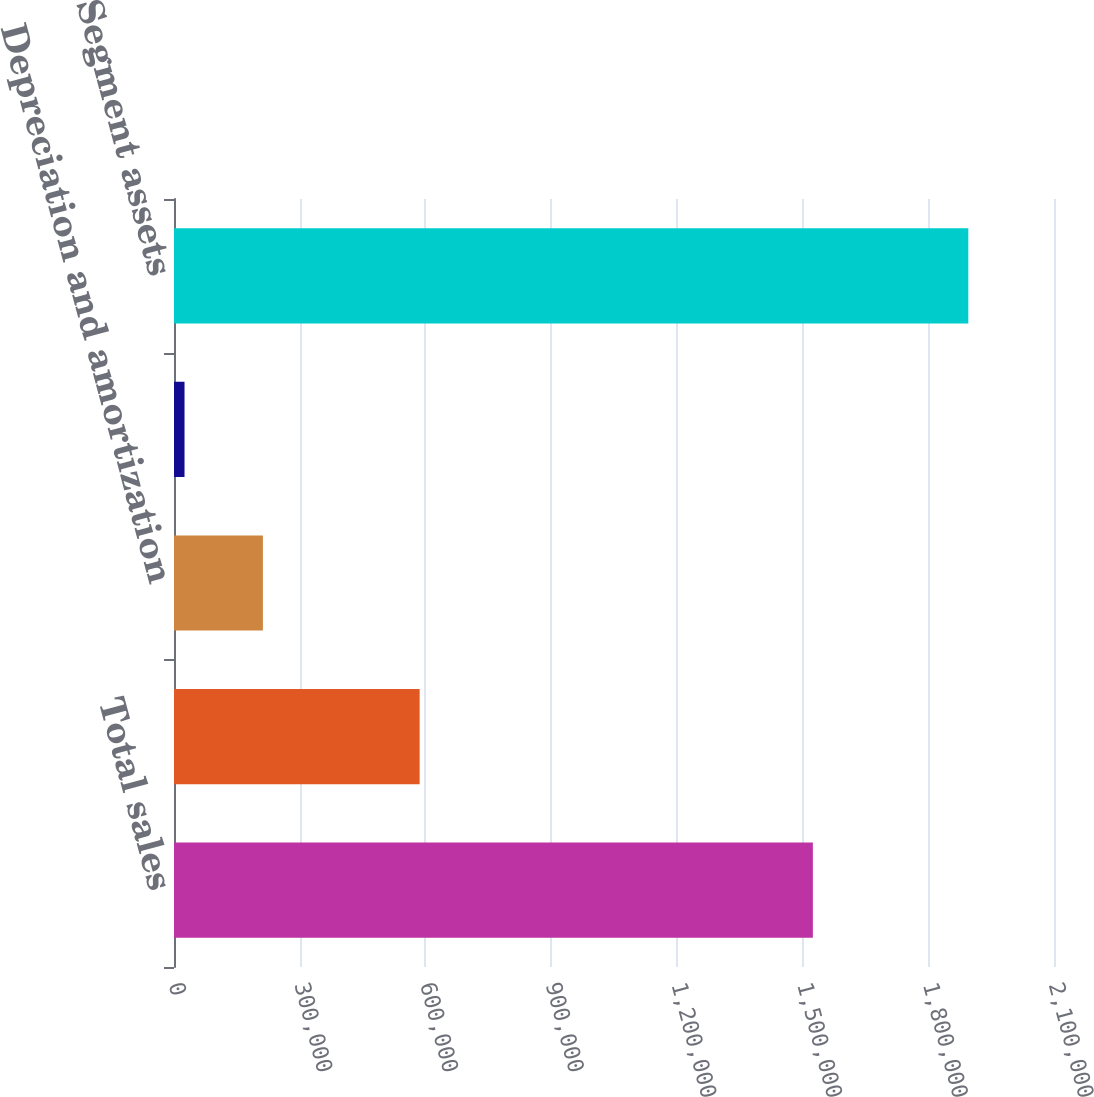Convert chart. <chart><loc_0><loc_0><loc_500><loc_500><bar_chart><fcel>Total sales<fcel>Income (loss) from operations<fcel>Depreciation and amortization<fcel>Capital expenditures<fcel>Segment assets<nl><fcel>1.52458e+06<fcel>586220<fcel>212137<fcel>25095<fcel>1.89551e+06<nl></chart> 